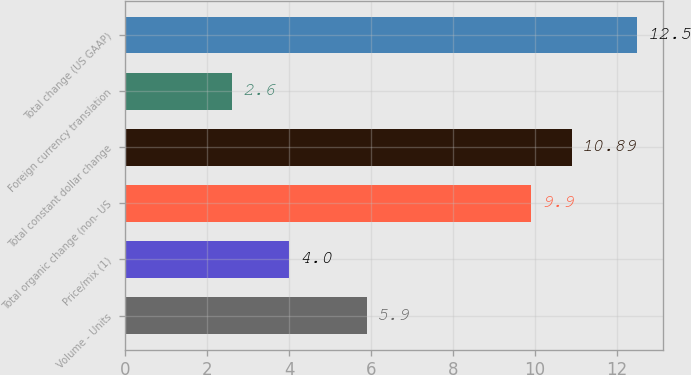<chart> <loc_0><loc_0><loc_500><loc_500><bar_chart><fcel>Volume - Units<fcel>Price/mix (1)<fcel>Total organic change (non- US<fcel>Total constant dollar change<fcel>Foreign currency translation<fcel>Total change (US GAAP)<nl><fcel>5.9<fcel>4<fcel>9.9<fcel>10.89<fcel>2.6<fcel>12.5<nl></chart> 